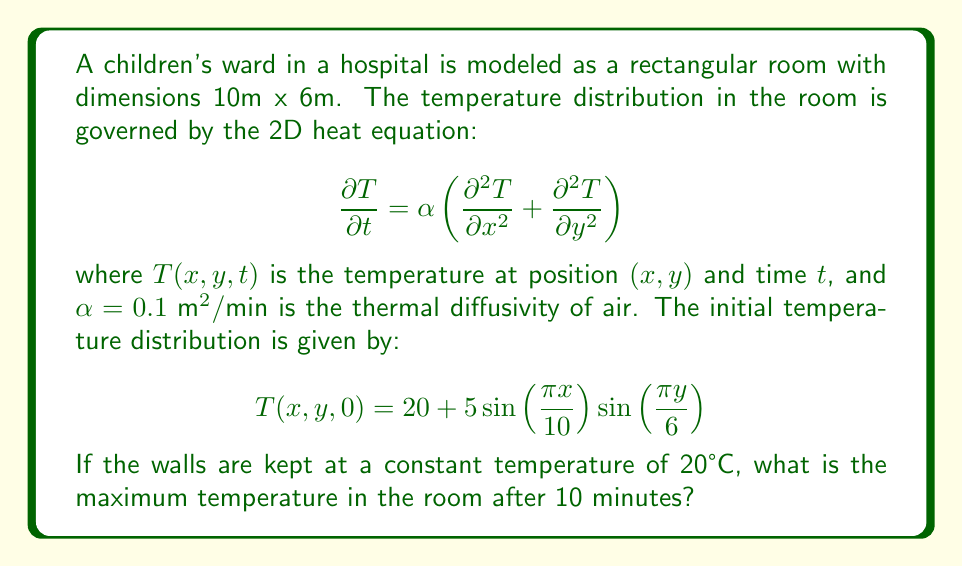Can you solve this math problem? To solve this problem, we need to use the separation of variables method for the heat equation with Dirichlet boundary conditions. The solution will have the form:

$$T(x,y,t) = 20 + \sum_{m=1}^{\infty}\sum_{n=1}^{\infty} A_{mn} \sin\left(\frac{m\pi x}{10}\right)\sin\left(\frac{n\pi y}{6}\right)e^{-\alpha(\frac{m^2\pi^2}{100}+\frac{n^2\pi^2}{36})t}$$

1) First, we need to find the coefficient $A_{11}$ by comparing the initial condition with the general solution at $t=0$:

   $$20 + 5\sin\left(\frac{\pi x}{10}\right)\sin\left(\frac{\pi y}{6}\right) = 20 + A_{11} \sin\left(\frac{\pi x}{10}\right)\sin\left(\frac{\pi y}{6}\right)$$

   Therefore, $A_{11} = 5$ and all other $A_{mn} = 0$ for $m \neq 1$ or $n \neq 1$.

2) Now, we can write the solution as:

   $$T(x,y,t) = 20 + 5\sin\left(\frac{\pi x}{10}\right)\sin\left(\frac{\pi y}{6}\right)e^{-\alpha(\frac{\pi^2}{100}+\frac{\pi^2}{36})t}$$

3) After 10 minutes, the temperature distribution will be:

   $$T(x,y,10) = 20 + 5\sin\left(\frac{\pi x}{10}\right)\sin\left(\frac{\pi y}{6}\right)e^{-0.1(\frac{\pi^2}{100}+\frac{\pi^2}{36})(10)}$$

4) The exponential term can be calculated:

   $$e^{-0.1(\frac{\pi^2}{100}+\frac{\pi^2}{36})(10)} \approx 0.3678$$

5) So, the temperature distribution after 10 minutes is:

   $$T(x,y,10) \approx 20 + 1.839\sin\left(\frac{\pi x}{10}\right)\sin\left(\frac{\pi y}{6}\right)$$

6) The maximum temperature will occur at the point where both sine terms are 1, which is at $(x,y) = (5,3)$.

7) The maximum temperature is therefore:

   $$T_{max} = 20 + 1.839 \approx 21.839°C$$
Answer: 21.839°C 